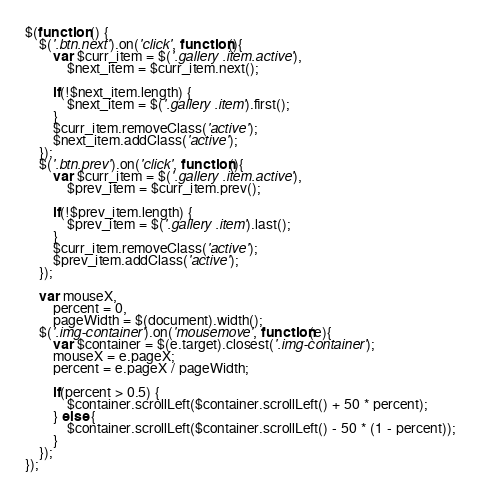<code> <loc_0><loc_0><loc_500><loc_500><_JavaScript_>$(function () {
    $('.btn.next').on('click', function(){
        var $curr_item = $('.gallery .item.active'),
            $next_item = $curr_item.next();

        if(!$next_item.length) {
            $next_item = $('.gallery .item').first();
        }
        $curr_item.removeClass('active');
        $next_item.addClass('active');
    });
    $('.btn.prev').on('click', function(){
        var $curr_item = $('.gallery .item.active'),
            $prev_item = $curr_item.prev();

        if(!$prev_item.length) {
            $prev_item = $('.gallery .item').last();
        }
        $curr_item.removeClass('active');
        $prev_item.addClass('active');
    });

    var mouseX,
        percent = 0,
        pageWidth = $(document).width();
    $('.img-container').on('mousemove', function(e){
        var $container = $(e.target).closest('.img-container');
        mouseX = e.pageX;
        percent = e.pageX / pageWidth;

        if(percent > 0.5) {
            $container.scrollLeft($container.scrollLeft() + 50 * percent);
        } else {
            $container.scrollLeft($container.scrollLeft() - 50 * (1 - percent));
        }
    });
});</code> 